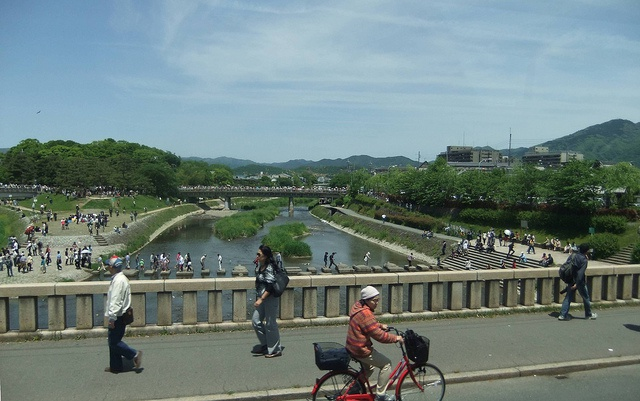Describe the objects in this image and their specific colors. I can see people in gray, black, darkgray, and darkgreen tones, bicycle in gray, black, darkgray, and maroon tones, people in gray, black, maroon, and brown tones, people in gray, black, purple, and darkblue tones, and people in gray, black, beige, and darkgray tones in this image. 